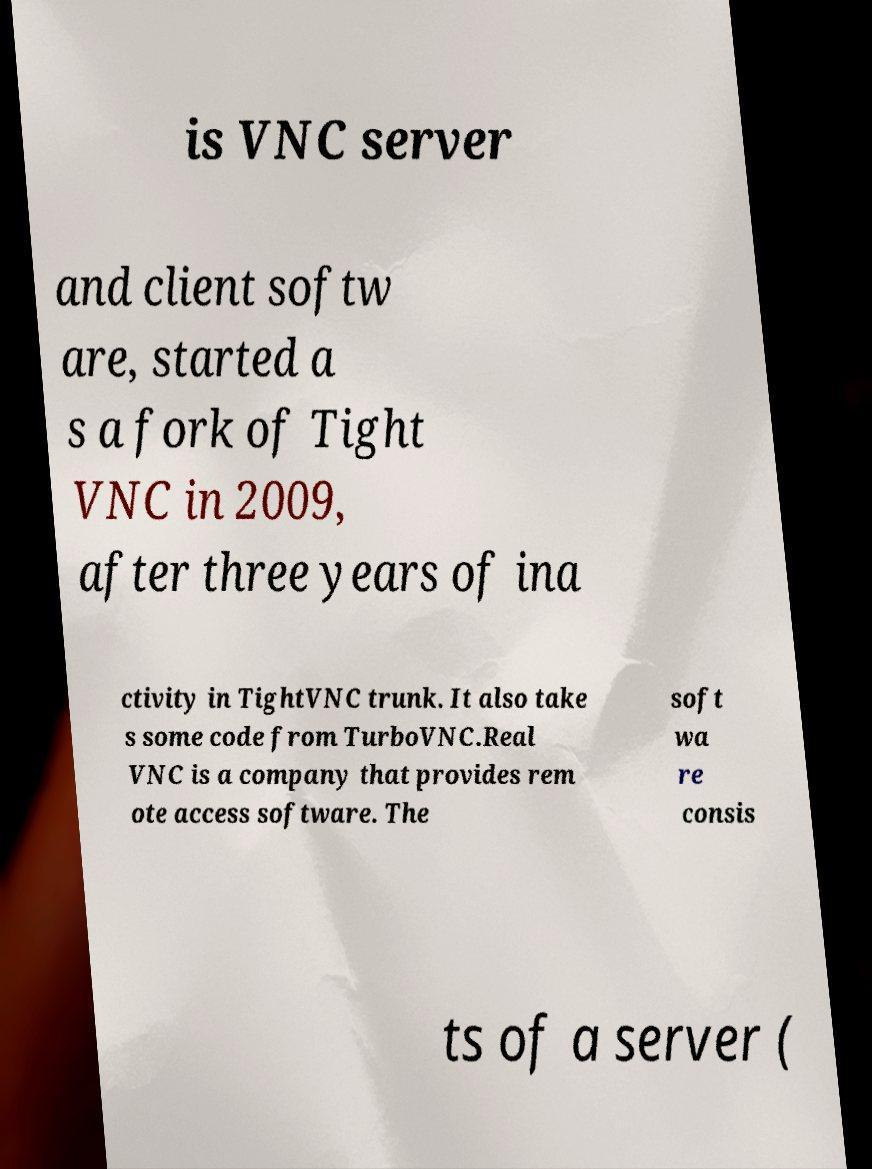Can you read and provide the text displayed in the image?This photo seems to have some interesting text. Can you extract and type it out for me? is VNC server and client softw are, started a s a fork of Tight VNC in 2009, after three years of ina ctivity in TightVNC trunk. It also take s some code from TurboVNC.Real VNC is a company that provides rem ote access software. The soft wa re consis ts of a server ( 